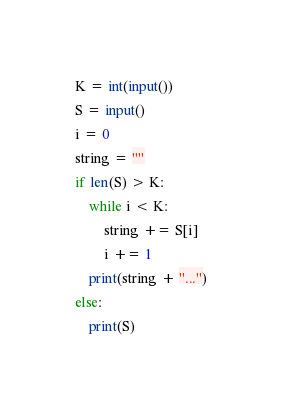<code> <loc_0><loc_0><loc_500><loc_500><_Python_>K = int(input())
S = input()
i = 0
string = ""
if len(S) > K:
    while i < K:
        string += S[i]
        i += 1
    print(string + "...")
else:
    print(S)</code> 